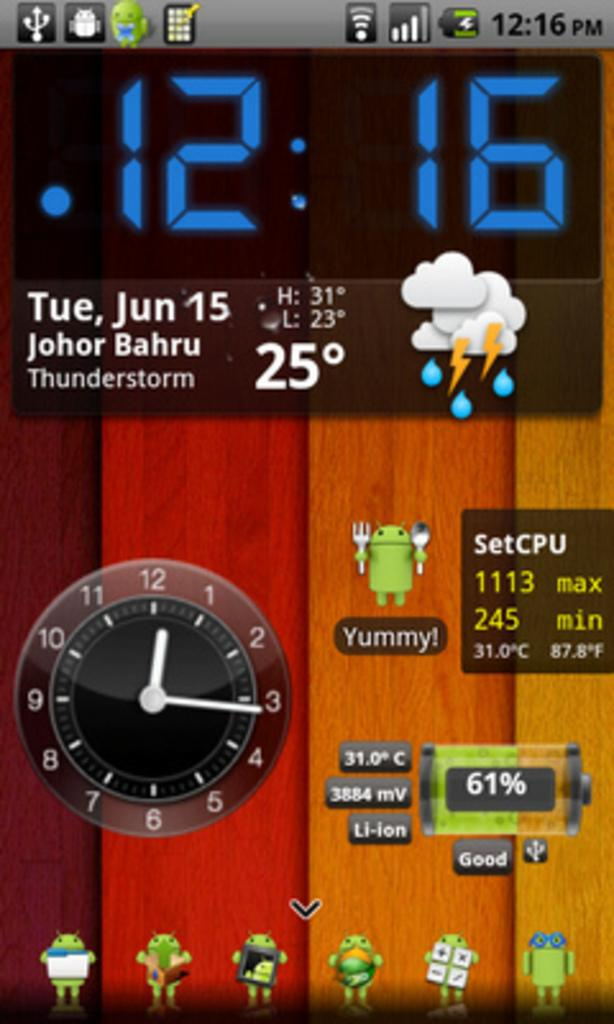<image>
Describe the image concisely. A device screen shows several different apps, and that the date is June 15. 